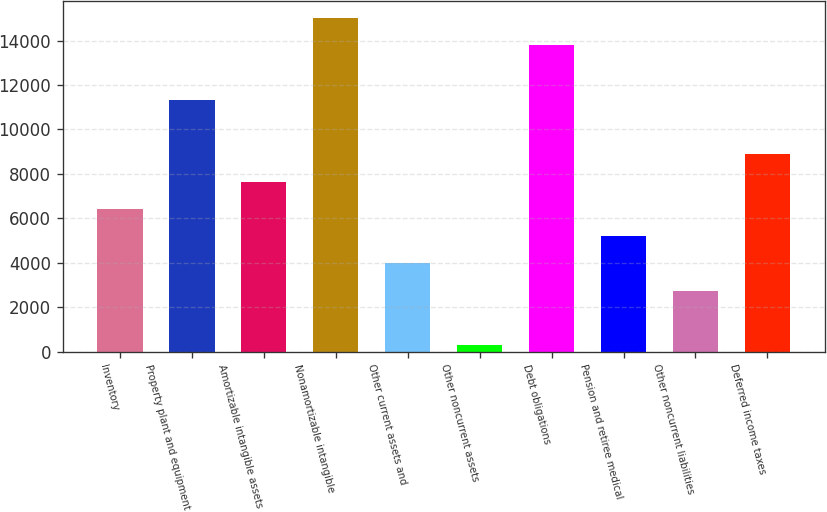Convert chart to OTSL. <chart><loc_0><loc_0><loc_500><loc_500><bar_chart><fcel>Inventory<fcel>Property plant and equipment<fcel>Amortizable intangible assets<fcel>Nonamortizable intangible<fcel>Other current assets and<fcel>Other noncurrent assets<fcel>Debt obligations<fcel>Pension and retiree medical<fcel>Other noncurrent liabilities<fcel>Deferred income taxes<nl><fcel>6418.5<fcel>11328.5<fcel>7646<fcel>15011<fcel>3963.5<fcel>281<fcel>13783.5<fcel>5191<fcel>2736<fcel>8873.5<nl></chart> 